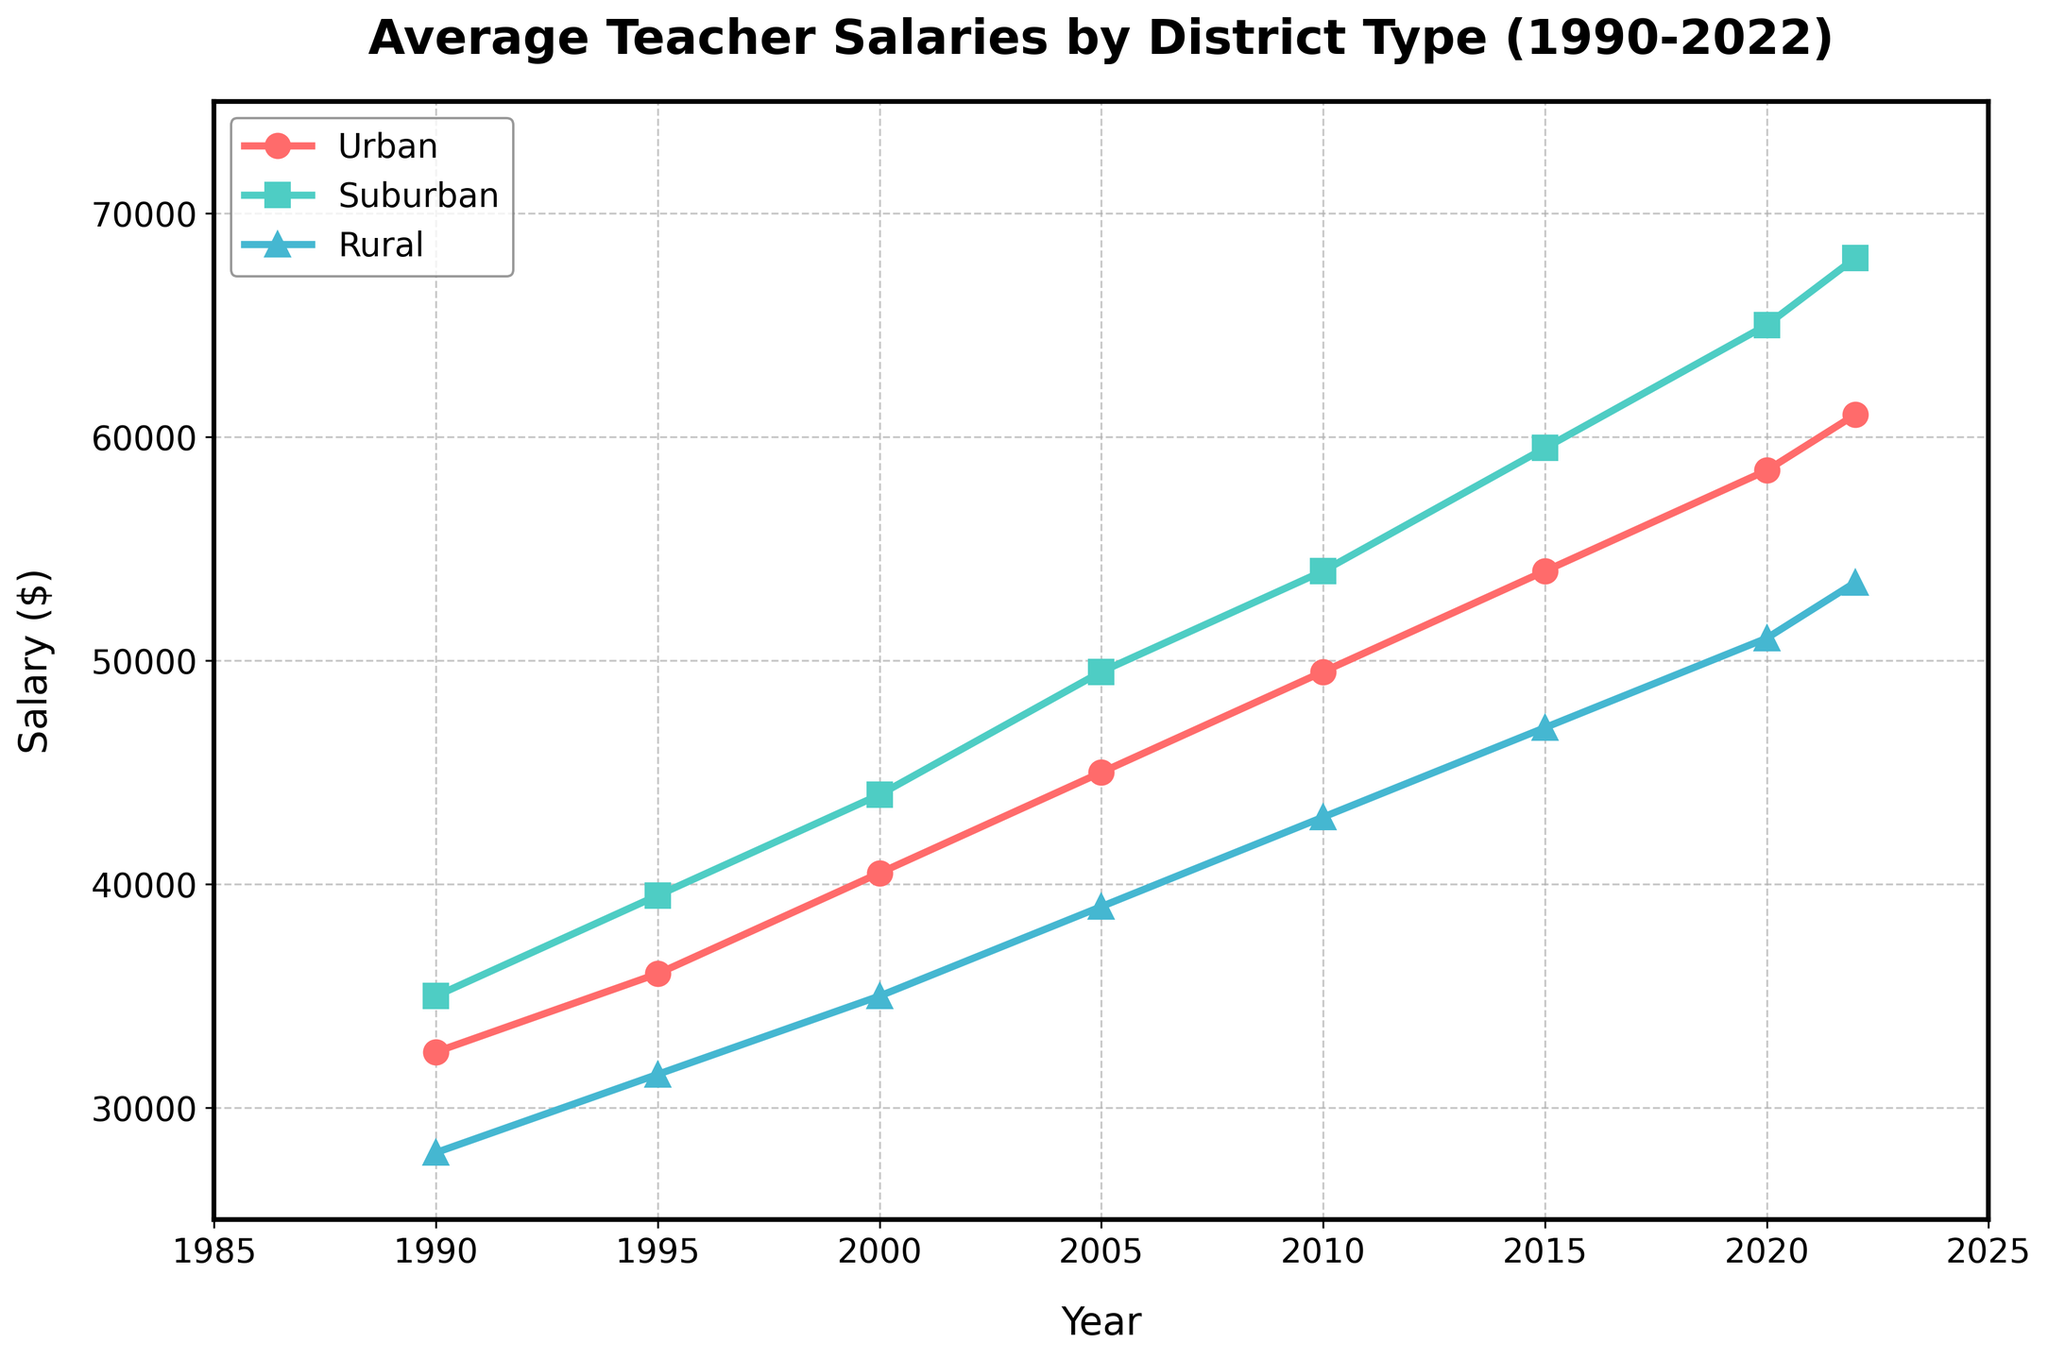What is the difference in average teacher salaries between urban and rural school districts in 1990? To find the difference, subtract the rural salary from the urban salary in 1990: 32500 (Urban) - 28000 (Rural) = 4500
Answer: 4500 Which category of school districts experienced the highest salary increase from 1990 to 2022? To determine the highest increase, calculate the difference between 2022 and 1990 salaries for each category: Urban: 61000 - 32500 = 28500, Suburban: 68000 - 35000 = 33000, Rural: 53500 - 28000 = 25500. The suburban district has the highest increase of 33000.
Answer: Suburban In which year did suburban school district salaries first exceed $50,000? Look at the suburban salary data: in 2005, the salary was 49500 and in 2010 it was 54000. So, suburban salaries first exceeded $50,000 in 2010.
Answer: 2010 How much did the salary in rural school districts increase from 2015 to 2022? Calculate the difference: 53500 (2022) - 47000 (2015) = 6500
Answer: 6500 Which district type had the highest average salary in 2022? Check the salaries for 2022: Urban 61000, Suburban 68000, Rural 53500. The suburban district type had the highest average salary.
Answer: Suburban What was the average salary of urban, suburban, and rural school districts combined in 2000? Sum up the salaries and divide by 3: (40500 + 44000 + 35000)/3 = 39833.33
Answer: 39833.33 Between 1990 and 2000, which district type had the least percentage increase in salaries? Calculate percentage increase for each district: Urban: (40500-32500)/32500*100 = 24.6%, Suburban: (44000-35000)/35000*100 = 25.7%, Rural: (35000-28000)/28000*100 = 25%. The urban district had the least percentage increase of 24.6%.
Answer: Urban By how much did the average salary of suburban school districts exceed rural school districts in 2015? Calculate the difference: 59500 (Suburban) - 47000 (Rural) = 12500
Answer: 12500 Which year shows the largest gap between urban and suburban teacher salaries? Calculate the gaps per year: 1990 (2500), 1995 (3500), 2000 (3500), 2005 (4500), 2010 (4500), 2015 (5500), 2020 (6500), 2022 (7000). The largest gap is in 2022 with a difference of 7000.
Answer: 2022 